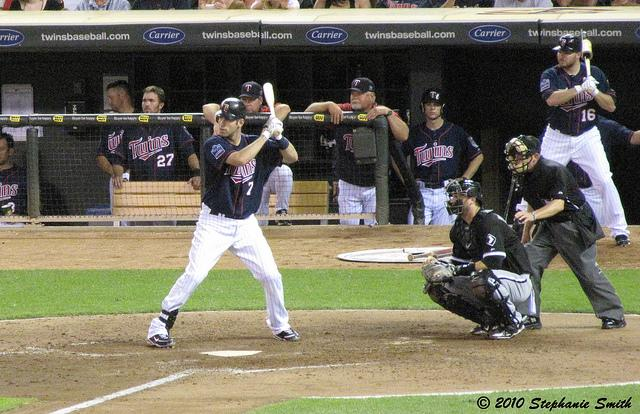What league does the team with the standing players play in? Please explain your reasoning. american league. The minnesota twins baseball team are batting. they do not play in the national league. 